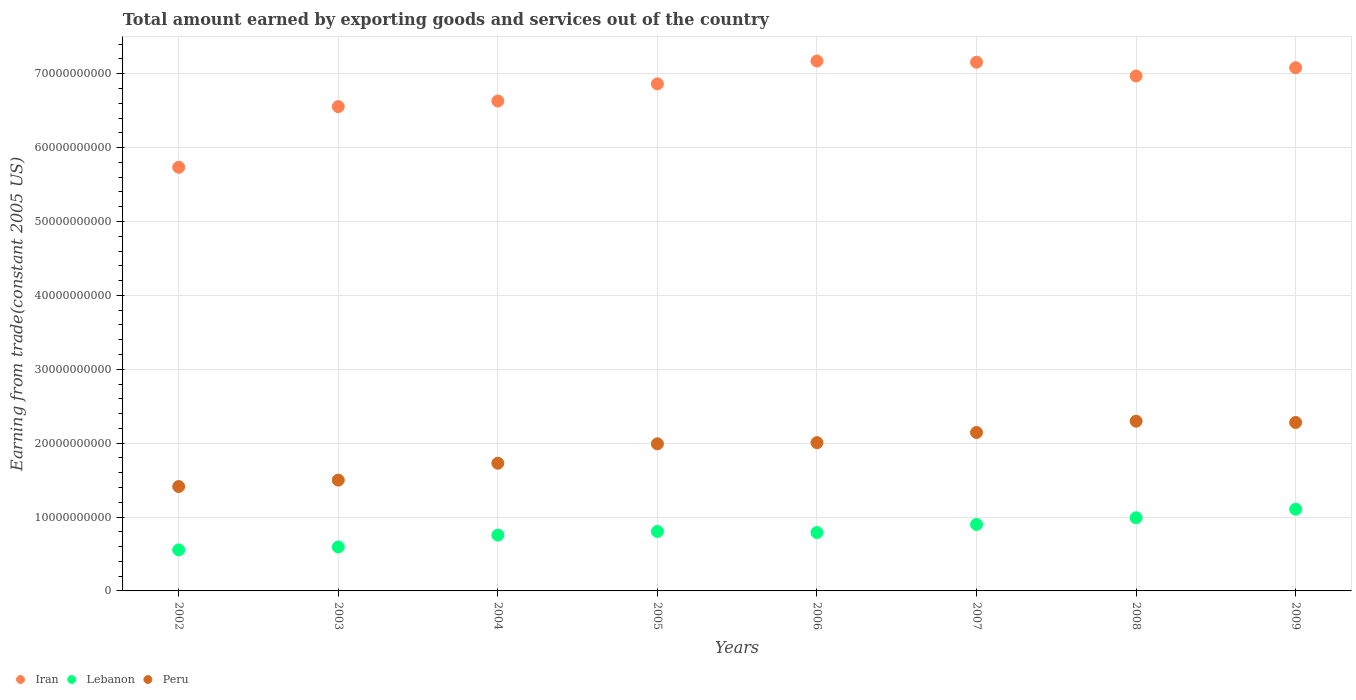Is the number of dotlines equal to the number of legend labels?
Your response must be concise. Yes. What is the total amount earned by exporting goods and services in Peru in 2003?
Keep it short and to the point. 1.50e+1. Across all years, what is the maximum total amount earned by exporting goods and services in Iran?
Ensure brevity in your answer.  7.17e+1. Across all years, what is the minimum total amount earned by exporting goods and services in Iran?
Offer a very short reply. 5.73e+1. What is the total total amount earned by exporting goods and services in Peru in the graph?
Offer a terse response. 1.54e+11. What is the difference between the total amount earned by exporting goods and services in Peru in 2002 and that in 2009?
Provide a short and direct response. -8.67e+09. What is the difference between the total amount earned by exporting goods and services in Peru in 2004 and the total amount earned by exporting goods and services in Lebanon in 2009?
Provide a short and direct response. 6.23e+09. What is the average total amount earned by exporting goods and services in Lebanon per year?
Give a very brief answer. 8.12e+09. In the year 2002, what is the difference between the total amount earned by exporting goods and services in Peru and total amount earned by exporting goods and services in Iran?
Make the answer very short. -4.32e+1. In how many years, is the total amount earned by exporting goods and services in Iran greater than 60000000000 US$?
Provide a succinct answer. 7. What is the ratio of the total amount earned by exporting goods and services in Iran in 2002 to that in 2009?
Give a very brief answer. 0.81. Is the difference between the total amount earned by exporting goods and services in Peru in 2007 and 2009 greater than the difference between the total amount earned by exporting goods and services in Iran in 2007 and 2009?
Give a very brief answer. No. What is the difference between the highest and the second highest total amount earned by exporting goods and services in Lebanon?
Your response must be concise. 1.15e+09. What is the difference between the highest and the lowest total amount earned by exporting goods and services in Lebanon?
Ensure brevity in your answer.  5.50e+09. In how many years, is the total amount earned by exporting goods and services in Peru greater than the average total amount earned by exporting goods and services in Peru taken over all years?
Provide a succinct answer. 5. Is it the case that in every year, the sum of the total amount earned by exporting goods and services in Lebanon and total amount earned by exporting goods and services in Peru  is greater than the total amount earned by exporting goods and services in Iran?
Offer a terse response. No. Does the total amount earned by exporting goods and services in Lebanon monotonically increase over the years?
Your answer should be compact. No. How many dotlines are there?
Your response must be concise. 3. Are the values on the major ticks of Y-axis written in scientific E-notation?
Provide a short and direct response. No. Does the graph contain grids?
Your response must be concise. Yes. Where does the legend appear in the graph?
Provide a succinct answer. Bottom left. How are the legend labels stacked?
Make the answer very short. Horizontal. What is the title of the graph?
Your response must be concise. Total amount earned by exporting goods and services out of the country. Does "Malta" appear as one of the legend labels in the graph?
Keep it short and to the point. No. What is the label or title of the X-axis?
Keep it short and to the point. Years. What is the label or title of the Y-axis?
Keep it short and to the point. Earning from trade(constant 2005 US). What is the Earning from trade(constant 2005 US) in Iran in 2002?
Your answer should be very brief. 5.73e+1. What is the Earning from trade(constant 2005 US) of Lebanon in 2002?
Your response must be concise. 5.56e+09. What is the Earning from trade(constant 2005 US) of Peru in 2002?
Ensure brevity in your answer.  1.41e+1. What is the Earning from trade(constant 2005 US) of Iran in 2003?
Offer a terse response. 6.56e+1. What is the Earning from trade(constant 2005 US) of Lebanon in 2003?
Offer a very short reply. 5.95e+09. What is the Earning from trade(constant 2005 US) in Peru in 2003?
Ensure brevity in your answer.  1.50e+1. What is the Earning from trade(constant 2005 US) in Iran in 2004?
Provide a short and direct response. 6.63e+1. What is the Earning from trade(constant 2005 US) of Lebanon in 2004?
Your answer should be compact. 7.56e+09. What is the Earning from trade(constant 2005 US) in Peru in 2004?
Make the answer very short. 1.73e+1. What is the Earning from trade(constant 2005 US) in Iran in 2005?
Keep it short and to the point. 6.86e+1. What is the Earning from trade(constant 2005 US) in Lebanon in 2005?
Provide a short and direct response. 8.05e+09. What is the Earning from trade(constant 2005 US) in Peru in 2005?
Your response must be concise. 1.99e+1. What is the Earning from trade(constant 2005 US) in Iran in 2006?
Provide a succinct answer. 7.17e+1. What is the Earning from trade(constant 2005 US) in Lebanon in 2006?
Ensure brevity in your answer.  7.91e+09. What is the Earning from trade(constant 2005 US) of Peru in 2006?
Make the answer very short. 2.01e+1. What is the Earning from trade(constant 2005 US) in Iran in 2007?
Provide a succinct answer. 7.16e+1. What is the Earning from trade(constant 2005 US) in Lebanon in 2007?
Make the answer very short. 9.00e+09. What is the Earning from trade(constant 2005 US) in Peru in 2007?
Provide a short and direct response. 2.14e+1. What is the Earning from trade(constant 2005 US) in Iran in 2008?
Your answer should be compact. 6.97e+1. What is the Earning from trade(constant 2005 US) in Lebanon in 2008?
Give a very brief answer. 9.91e+09. What is the Earning from trade(constant 2005 US) of Peru in 2008?
Offer a terse response. 2.30e+1. What is the Earning from trade(constant 2005 US) in Iran in 2009?
Your response must be concise. 7.08e+1. What is the Earning from trade(constant 2005 US) of Lebanon in 2009?
Make the answer very short. 1.11e+1. What is the Earning from trade(constant 2005 US) of Peru in 2009?
Offer a terse response. 2.28e+1. Across all years, what is the maximum Earning from trade(constant 2005 US) of Iran?
Your answer should be very brief. 7.17e+1. Across all years, what is the maximum Earning from trade(constant 2005 US) in Lebanon?
Your response must be concise. 1.11e+1. Across all years, what is the maximum Earning from trade(constant 2005 US) of Peru?
Offer a very short reply. 2.30e+1. Across all years, what is the minimum Earning from trade(constant 2005 US) of Iran?
Ensure brevity in your answer.  5.73e+1. Across all years, what is the minimum Earning from trade(constant 2005 US) in Lebanon?
Make the answer very short. 5.56e+09. Across all years, what is the minimum Earning from trade(constant 2005 US) of Peru?
Your answer should be compact. 1.41e+1. What is the total Earning from trade(constant 2005 US) of Iran in the graph?
Your response must be concise. 5.42e+11. What is the total Earning from trade(constant 2005 US) of Lebanon in the graph?
Keep it short and to the point. 6.50e+1. What is the total Earning from trade(constant 2005 US) in Peru in the graph?
Offer a terse response. 1.54e+11. What is the difference between the Earning from trade(constant 2005 US) of Iran in 2002 and that in 2003?
Provide a short and direct response. -8.21e+09. What is the difference between the Earning from trade(constant 2005 US) of Lebanon in 2002 and that in 2003?
Provide a succinct answer. -3.94e+08. What is the difference between the Earning from trade(constant 2005 US) of Peru in 2002 and that in 2003?
Offer a terse response. -8.71e+08. What is the difference between the Earning from trade(constant 2005 US) of Iran in 2002 and that in 2004?
Offer a very short reply. -8.97e+09. What is the difference between the Earning from trade(constant 2005 US) of Lebanon in 2002 and that in 2004?
Provide a succinct answer. -2.00e+09. What is the difference between the Earning from trade(constant 2005 US) in Peru in 2002 and that in 2004?
Your answer should be compact. -3.16e+09. What is the difference between the Earning from trade(constant 2005 US) of Iran in 2002 and that in 2005?
Ensure brevity in your answer.  -1.13e+1. What is the difference between the Earning from trade(constant 2005 US) of Lebanon in 2002 and that in 2005?
Make the answer very short. -2.49e+09. What is the difference between the Earning from trade(constant 2005 US) in Peru in 2002 and that in 2005?
Provide a short and direct response. -5.78e+09. What is the difference between the Earning from trade(constant 2005 US) of Iran in 2002 and that in 2006?
Ensure brevity in your answer.  -1.44e+1. What is the difference between the Earning from trade(constant 2005 US) of Lebanon in 2002 and that in 2006?
Your answer should be very brief. -2.35e+09. What is the difference between the Earning from trade(constant 2005 US) in Peru in 2002 and that in 2006?
Your answer should be very brief. -5.94e+09. What is the difference between the Earning from trade(constant 2005 US) of Iran in 2002 and that in 2007?
Provide a short and direct response. -1.42e+1. What is the difference between the Earning from trade(constant 2005 US) in Lebanon in 2002 and that in 2007?
Provide a short and direct response. -3.44e+09. What is the difference between the Earning from trade(constant 2005 US) in Peru in 2002 and that in 2007?
Provide a succinct answer. -7.32e+09. What is the difference between the Earning from trade(constant 2005 US) in Iran in 2002 and that in 2008?
Provide a short and direct response. -1.24e+1. What is the difference between the Earning from trade(constant 2005 US) of Lebanon in 2002 and that in 2008?
Your response must be concise. -4.35e+09. What is the difference between the Earning from trade(constant 2005 US) in Peru in 2002 and that in 2008?
Make the answer very short. -8.84e+09. What is the difference between the Earning from trade(constant 2005 US) of Iran in 2002 and that in 2009?
Give a very brief answer. -1.35e+1. What is the difference between the Earning from trade(constant 2005 US) in Lebanon in 2002 and that in 2009?
Your answer should be compact. -5.50e+09. What is the difference between the Earning from trade(constant 2005 US) of Peru in 2002 and that in 2009?
Keep it short and to the point. -8.67e+09. What is the difference between the Earning from trade(constant 2005 US) of Iran in 2003 and that in 2004?
Your answer should be compact. -7.56e+08. What is the difference between the Earning from trade(constant 2005 US) in Lebanon in 2003 and that in 2004?
Your response must be concise. -1.61e+09. What is the difference between the Earning from trade(constant 2005 US) of Peru in 2003 and that in 2004?
Ensure brevity in your answer.  -2.28e+09. What is the difference between the Earning from trade(constant 2005 US) of Iran in 2003 and that in 2005?
Offer a terse response. -3.08e+09. What is the difference between the Earning from trade(constant 2005 US) of Lebanon in 2003 and that in 2005?
Give a very brief answer. -2.10e+09. What is the difference between the Earning from trade(constant 2005 US) of Peru in 2003 and that in 2005?
Provide a short and direct response. -4.91e+09. What is the difference between the Earning from trade(constant 2005 US) in Iran in 2003 and that in 2006?
Ensure brevity in your answer.  -6.17e+09. What is the difference between the Earning from trade(constant 2005 US) in Lebanon in 2003 and that in 2006?
Your response must be concise. -1.96e+09. What is the difference between the Earning from trade(constant 2005 US) in Peru in 2003 and that in 2006?
Offer a very short reply. -5.07e+09. What is the difference between the Earning from trade(constant 2005 US) in Iran in 2003 and that in 2007?
Your answer should be compact. -6.01e+09. What is the difference between the Earning from trade(constant 2005 US) of Lebanon in 2003 and that in 2007?
Make the answer very short. -3.05e+09. What is the difference between the Earning from trade(constant 2005 US) of Peru in 2003 and that in 2007?
Offer a very short reply. -6.45e+09. What is the difference between the Earning from trade(constant 2005 US) in Iran in 2003 and that in 2008?
Make the answer very short. -4.15e+09. What is the difference between the Earning from trade(constant 2005 US) in Lebanon in 2003 and that in 2008?
Give a very brief answer. -3.95e+09. What is the difference between the Earning from trade(constant 2005 US) in Peru in 2003 and that in 2008?
Your answer should be very brief. -7.97e+09. What is the difference between the Earning from trade(constant 2005 US) of Iran in 2003 and that in 2009?
Keep it short and to the point. -5.27e+09. What is the difference between the Earning from trade(constant 2005 US) of Lebanon in 2003 and that in 2009?
Offer a very short reply. -5.11e+09. What is the difference between the Earning from trade(constant 2005 US) in Peru in 2003 and that in 2009?
Offer a very short reply. -7.80e+09. What is the difference between the Earning from trade(constant 2005 US) in Iran in 2004 and that in 2005?
Provide a succinct answer. -2.32e+09. What is the difference between the Earning from trade(constant 2005 US) of Lebanon in 2004 and that in 2005?
Provide a short and direct response. -4.93e+08. What is the difference between the Earning from trade(constant 2005 US) in Peru in 2004 and that in 2005?
Your answer should be compact. -2.63e+09. What is the difference between the Earning from trade(constant 2005 US) in Iran in 2004 and that in 2006?
Your answer should be very brief. -5.41e+09. What is the difference between the Earning from trade(constant 2005 US) in Lebanon in 2004 and that in 2006?
Ensure brevity in your answer.  -3.49e+08. What is the difference between the Earning from trade(constant 2005 US) of Peru in 2004 and that in 2006?
Offer a terse response. -2.79e+09. What is the difference between the Earning from trade(constant 2005 US) of Iran in 2004 and that in 2007?
Provide a succinct answer. -5.25e+09. What is the difference between the Earning from trade(constant 2005 US) of Lebanon in 2004 and that in 2007?
Make the answer very short. -1.44e+09. What is the difference between the Earning from trade(constant 2005 US) in Peru in 2004 and that in 2007?
Your answer should be very brief. -4.16e+09. What is the difference between the Earning from trade(constant 2005 US) of Iran in 2004 and that in 2008?
Your response must be concise. -3.39e+09. What is the difference between the Earning from trade(constant 2005 US) of Lebanon in 2004 and that in 2008?
Your answer should be very brief. -2.35e+09. What is the difference between the Earning from trade(constant 2005 US) of Peru in 2004 and that in 2008?
Give a very brief answer. -5.69e+09. What is the difference between the Earning from trade(constant 2005 US) of Iran in 2004 and that in 2009?
Make the answer very short. -4.51e+09. What is the difference between the Earning from trade(constant 2005 US) in Lebanon in 2004 and that in 2009?
Offer a terse response. -3.50e+09. What is the difference between the Earning from trade(constant 2005 US) of Peru in 2004 and that in 2009?
Your answer should be compact. -5.52e+09. What is the difference between the Earning from trade(constant 2005 US) in Iran in 2005 and that in 2006?
Keep it short and to the point. -3.09e+09. What is the difference between the Earning from trade(constant 2005 US) in Lebanon in 2005 and that in 2006?
Give a very brief answer. 1.44e+08. What is the difference between the Earning from trade(constant 2005 US) of Peru in 2005 and that in 2006?
Ensure brevity in your answer.  -1.59e+08. What is the difference between the Earning from trade(constant 2005 US) in Iran in 2005 and that in 2007?
Keep it short and to the point. -2.93e+09. What is the difference between the Earning from trade(constant 2005 US) of Lebanon in 2005 and that in 2007?
Make the answer very short. -9.45e+08. What is the difference between the Earning from trade(constant 2005 US) in Peru in 2005 and that in 2007?
Offer a terse response. -1.53e+09. What is the difference between the Earning from trade(constant 2005 US) of Iran in 2005 and that in 2008?
Make the answer very short. -1.07e+09. What is the difference between the Earning from trade(constant 2005 US) in Lebanon in 2005 and that in 2008?
Offer a terse response. -1.85e+09. What is the difference between the Earning from trade(constant 2005 US) in Peru in 2005 and that in 2008?
Provide a succinct answer. -3.06e+09. What is the difference between the Earning from trade(constant 2005 US) in Iran in 2005 and that in 2009?
Make the answer very short. -2.19e+09. What is the difference between the Earning from trade(constant 2005 US) of Lebanon in 2005 and that in 2009?
Provide a short and direct response. -3.01e+09. What is the difference between the Earning from trade(constant 2005 US) of Peru in 2005 and that in 2009?
Offer a very short reply. -2.89e+09. What is the difference between the Earning from trade(constant 2005 US) of Iran in 2006 and that in 2007?
Give a very brief answer. 1.61e+08. What is the difference between the Earning from trade(constant 2005 US) in Lebanon in 2006 and that in 2007?
Provide a succinct answer. -1.09e+09. What is the difference between the Earning from trade(constant 2005 US) of Peru in 2006 and that in 2007?
Your response must be concise. -1.37e+09. What is the difference between the Earning from trade(constant 2005 US) in Iran in 2006 and that in 2008?
Provide a short and direct response. 2.02e+09. What is the difference between the Earning from trade(constant 2005 US) of Lebanon in 2006 and that in 2008?
Provide a succinct answer. -2.00e+09. What is the difference between the Earning from trade(constant 2005 US) in Peru in 2006 and that in 2008?
Your answer should be very brief. -2.90e+09. What is the difference between the Earning from trade(constant 2005 US) in Iran in 2006 and that in 2009?
Your answer should be very brief. 9.05e+08. What is the difference between the Earning from trade(constant 2005 US) in Lebanon in 2006 and that in 2009?
Your answer should be compact. -3.15e+09. What is the difference between the Earning from trade(constant 2005 US) of Peru in 2006 and that in 2009?
Provide a succinct answer. -2.73e+09. What is the difference between the Earning from trade(constant 2005 US) in Iran in 2007 and that in 2008?
Your response must be concise. 1.86e+09. What is the difference between the Earning from trade(constant 2005 US) in Lebanon in 2007 and that in 2008?
Keep it short and to the point. -9.10e+08. What is the difference between the Earning from trade(constant 2005 US) of Peru in 2007 and that in 2008?
Your response must be concise. -1.52e+09. What is the difference between the Earning from trade(constant 2005 US) in Iran in 2007 and that in 2009?
Offer a terse response. 7.44e+08. What is the difference between the Earning from trade(constant 2005 US) in Lebanon in 2007 and that in 2009?
Provide a short and direct response. -2.06e+09. What is the difference between the Earning from trade(constant 2005 US) of Peru in 2007 and that in 2009?
Provide a short and direct response. -1.36e+09. What is the difference between the Earning from trade(constant 2005 US) of Iran in 2008 and that in 2009?
Give a very brief answer. -1.12e+09. What is the difference between the Earning from trade(constant 2005 US) in Lebanon in 2008 and that in 2009?
Make the answer very short. -1.15e+09. What is the difference between the Earning from trade(constant 2005 US) in Peru in 2008 and that in 2009?
Keep it short and to the point. 1.67e+08. What is the difference between the Earning from trade(constant 2005 US) in Iran in 2002 and the Earning from trade(constant 2005 US) in Lebanon in 2003?
Offer a very short reply. 5.14e+1. What is the difference between the Earning from trade(constant 2005 US) in Iran in 2002 and the Earning from trade(constant 2005 US) in Peru in 2003?
Ensure brevity in your answer.  4.23e+1. What is the difference between the Earning from trade(constant 2005 US) in Lebanon in 2002 and the Earning from trade(constant 2005 US) in Peru in 2003?
Provide a short and direct response. -9.44e+09. What is the difference between the Earning from trade(constant 2005 US) in Iran in 2002 and the Earning from trade(constant 2005 US) in Lebanon in 2004?
Give a very brief answer. 4.98e+1. What is the difference between the Earning from trade(constant 2005 US) of Iran in 2002 and the Earning from trade(constant 2005 US) of Peru in 2004?
Your response must be concise. 4.01e+1. What is the difference between the Earning from trade(constant 2005 US) of Lebanon in 2002 and the Earning from trade(constant 2005 US) of Peru in 2004?
Provide a short and direct response. -1.17e+1. What is the difference between the Earning from trade(constant 2005 US) in Iran in 2002 and the Earning from trade(constant 2005 US) in Lebanon in 2005?
Offer a terse response. 4.93e+1. What is the difference between the Earning from trade(constant 2005 US) in Iran in 2002 and the Earning from trade(constant 2005 US) in Peru in 2005?
Your response must be concise. 3.74e+1. What is the difference between the Earning from trade(constant 2005 US) in Lebanon in 2002 and the Earning from trade(constant 2005 US) in Peru in 2005?
Make the answer very short. -1.44e+1. What is the difference between the Earning from trade(constant 2005 US) in Iran in 2002 and the Earning from trade(constant 2005 US) in Lebanon in 2006?
Ensure brevity in your answer.  4.94e+1. What is the difference between the Earning from trade(constant 2005 US) of Iran in 2002 and the Earning from trade(constant 2005 US) of Peru in 2006?
Give a very brief answer. 3.73e+1. What is the difference between the Earning from trade(constant 2005 US) in Lebanon in 2002 and the Earning from trade(constant 2005 US) in Peru in 2006?
Provide a short and direct response. -1.45e+1. What is the difference between the Earning from trade(constant 2005 US) of Iran in 2002 and the Earning from trade(constant 2005 US) of Lebanon in 2007?
Give a very brief answer. 4.83e+1. What is the difference between the Earning from trade(constant 2005 US) in Iran in 2002 and the Earning from trade(constant 2005 US) in Peru in 2007?
Provide a short and direct response. 3.59e+1. What is the difference between the Earning from trade(constant 2005 US) in Lebanon in 2002 and the Earning from trade(constant 2005 US) in Peru in 2007?
Offer a very short reply. -1.59e+1. What is the difference between the Earning from trade(constant 2005 US) of Iran in 2002 and the Earning from trade(constant 2005 US) of Lebanon in 2008?
Your response must be concise. 4.74e+1. What is the difference between the Earning from trade(constant 2005 US) of Iran in 2002 and the Earning from trade(constant 2005 US) of Peru in 2008?
Make the answer very short. 3.44e+1. What is the difference between the Earning from trade(constant 2005 US) in Lebanon in 2002 and the Earning from trade(constant 2005 US) in Peru in 2008?
Make the answer very short. -1.74e+1. What is the difference between the Earning from trade(constant 2005 US) of Iran in 2002 and the Earning from trade(constant 2005 US) of Lebanon in 2009?
Your answer should be compact. 4.63e+1. What is the difference between the Earning from trade(constant 2005 US) of Iran in 2002 and the Earning from trade(constant 2005 US) of Peru in 2009?
Offer a very short reply. 3.45e+1. What is the difference between the Earning from trade(constant 2005 US) in Lebanon in 2002 and the Earning from trade(constant 2005 US) in Peru in 2009?
Your response must be concise. -1.72e+1. What is the difference between the Earning from trade(constant 2005 US) of Iran in 2003 and the Earning from trade(constant 2005 US) of Lebanon in 2004?
Provide a short and direct response. 5.80e+1. What is the difference between the Earning from trade(constant 2005 US) of Iran in 2003 and the Earning from trade(constant 2005 US) of Peru in 2004?
Ensure brevity in your answer.  4.83e+1. What is the difference between the Earning from trade(constant 2005 US) of Lebanon in 2003 and the Earning from trade(constant 2005 US) of Peru in 2004?
Provide a succinct answer. -1.13e+1. What is the difference between the Earning from trade(constant 2005 US) of Iran in 2003 and the Earning from trade(constant 2005 US) of Lebanon in 2005?
Your answer should be very brief. 5.75e+1. What is the difference between the Earning from trade(constant 2005 US) of Iran in 2003 and the Earning from trade(constant 2005 US) of Peru in 2005?
Your answer should be compact. 4.56e+1. What is the difference between the Earning from trade(constant 2005 US) of Lebanon in 2003 and the Earning from trade(constant 2005 US) of Peru in 2005?
Offer a terse response. -1.40e+1. What is the difference between the Earning from trade(constant 2005 US) in Iran in 2003 and the Earning from trade(constant 2005 US) in Lebanon in 2006?
Provide a short and direct response. 5.77e+1. What is the difference between the Earning from trade(constant 2005 US) of Iran in 2003 and the Earning from trade(constant 2005 US) of Peru in 2006?
Offer a terse response. 4.55e+1. What is the difference between the Earning from trade(constant 2005 US) in Lebanon in 2003 and the Earning from trade(constant 2005 US) in Peru in 2006?
Your answer should be very brief. -1.41e+1. What is the difference between the Earning from trade(constant 2005 US) in Iran in 2003 and the Earning from trade(constant 2005 US) in Lebanon in 2007?
Your answer should be very brief. 5.66e+1. What is the difference between the Earning from trade(constant 2005 US) in Iran in 2003 and the Earning from trade(constant 2005 US) in Peru in 2007?
Your answer should be very brief. 4.41e+1. What is the difference between the Earning from trade(constant 2005 US) in Lebanon in 2003 and the Earning from trade(constant 2005 US) in Peru in 2007?
Your answer should be compact. -1.55e+1. What is the difference between the Earning from trade(constant 2005 US) of Iran in 2003 and the Earning from trade(constant 2005 US) of Lebanon in 2008?
Offer a very short reply. 5.57e+1. What is the difference between the Earning from trade(constant 2005 US) of Iran in 2003 and the Earning from trade(constant 2005 US) of Peru in 2008?
Give a very brief answer. 4.26e+1. What is the difference between the Earning from trade(constant 2005 US) in Lebanon in 2003 and the Earning from trade(constant 2005 US) in Peru in 2008?
Your response must be concise. -1.70e+1. What is the difference between the Earning from trade(constant 2005 US) in Iran in 2003 and the Earning from trade(constant 2005 US) in Lebanon in 2009?
Make the answer very short. 5.45e+1. What is the difference between the Earning from trade(constant 2005 US) of Iran in 2003 and the Earning from trade(constant 2005 US) of Peru in 2009?
Offer a very short reply. 4.28e+1. What is the difference between the Earning from trade(constant 2005 US) in Lebanon in 2003 and the Earning from trade(constant 2005 US) in Peru in 2009?
Offer a terse response. -1.69e+1. What is the difference between the Earning from trade(constant 2005 US) in Iran in 2004 and the Earning from trade(constant 2005 US) in Lebanon in 2005?
Make the answer very short. 5.83e+1. What is the difference between the Earning from trade(constant 2005 US) in Iran in 2004 and the Earning from trade(constant 2005 US) in Peru in 2005?
Make the answer very short. 4.64e+1. What is the difference between the Earning from trade(constant 2005 US) in Lebanon in 2004 and the Earning from trade(constant 2005 US) in Peru in 2005?
Your response must be concise. -1.24e+1. What is the difference between the Earning from trade(constant 2005 US) in Iran in 2004 and the Earning from trade(constant 2005 US) in Lebanon in 2006?
Your answer should be very brief. 5.84e+1. What is the difference between the Earning from trade(constant 2005 US) of Iran in 2004 and the Earning from trade(constant 2005 US) of Peru in 2006?
Your response must be concise. 4.62e+1. What is the difference between the Earning from trade(constant 2005 US) of Lebanon in 2004 and the Earning from trade(constant 2005 US) of Peru in 2006?
Offer a terse response. -1.25e+1. What is the difference between the Earning from trade(constant 2005 US) of Iran in 2004 and the Earning from trade(constant 2005 US) of Lebanon in 2007?
Your answer should be very brief. 5.73e+1. What is the difference between the Earning from trade(constant 2005 US) in Iran in 2004 and the Earning from trade(constant 2005 US) in Peru in 2007?
Your answer should be compact. 4.49e+1. What is the difference between the Earning from trade(constant 2005 US) of Lebanon in 2004 and the Earning from trade(constant 2005 US) of Peru in 2007?
Give a very brief answer. -1.39e+1. What is the difference between the Earning from trade(constant 2005 US) of Iran in 2004 and the Earning from trade(constant 2005 US) of Lebanon in 2008?
Offer a very short reply. 5.64e+1. What is the difference between the Earning from trade(constant 2005 US) of Iran in 2004 and the Earning from trade(constant 2005 US) of Peru in 2008?
Make the answer very short. 4.33e+1. What is the difference between the Earning from trade(constant 2005 US) of Lebanon in 2004 and the Earning from trade(constant 2005 US) of Peru in 2008?
Your answer should be compact. -1.54e+1. What is the difference between the Earning from trade(constant 2005 US) of Iran in 2004 and the Earning from trade(constant 2005 US) of Lebanon in 2009?
Offer a very short reply. 5.53e+1. What is the difference between the Earning from trade(constant 2005 US) in Iran in 2004 and the Earning from trade(constant 2005 US) in Peru in 2009?
Offer a terse response. 4.35e+1. What is the difference between the Earning from trade(constant 2005 US) of Lebanon in 2004 and the Earning from trade(constant 2005 US) of Peru in 2009?
Offer a very short reply. -1.52e+1. What is the difference between the Earning from trade(constant 2005 US) of Iran in 2005 and the Earning from trade(constant 2005 US) of Lebanon in 2006?
Offer a very short reply. 6.07e+1. What is the difference between the Earning from trade(constant 2005 US) of Iran in 2005 and the Earning from trade(constant 2005 US) of Peru in 2006?
Provide a short and direct response. 4.86e+1. What is the difference between the Earning from trade(constant 2005 US) in Lebanon in 2005 and the Earning from trade(constant 2005 US) in Peru in 2006?
Your answer should be very brief. -1.20e+1. What is the difference between the Earning from trade(constant 2005 US) of Iran in 2005 and the Earning from trade(constant 2005 US) of Lebanon in 2007?
Provide a short and direct response. 5.96e+1. What is the difference between the Earning from trade(constant 2005 US) of Iran in 2005 and the Earning from trade(constant 2005 US) of Peru in 2007?
Provide a short and direct response. 4.72e+1. What is the difference between the Earning from trade(constant 2005 US) in Lebanon in 2005 and the Earning from trade(constant 2005 US) in Peru in 2007?
Provide a short and direct response. -1.34e+1. What is the difference between the Earning from trade(constant 2005 US) of Iran in 2005 and the Earning from trade(constant 2005 US) of Lebanon in 2008?
Offer a terse response. 5.87e+1. What is the difference between the Earning from trade(constant 2005 US) in Iran in 2005 and the Earning from trade(constant 2005 US) in Peru in 2008?
Ensure brevity in your answer.  4.57e+1. What is the difference between the Earning from trade(constant 2005 US) of Lebanon in 2005 and the Earning from trade(constant 2005 US) of Peru in 2008?
Offer a very short reply. -1.49e+1. What is the difference between the Earning from trade(constant 2005 US) of Iran in 2005 and the Earning from trade(constant 2005 US) of Lebanon in 2009?
Keep it short and to the point. 5.76e+1. What is the difference between the Earning from trade(constant 2005 US) of Iran in 2005 and the Earning from trade(constant 2005 US) of Peru in 2009?
Your answer should be very brief. 4.58e+1. What is the difference between the Earning from trade(constant 2005 US) of Lebanon in 2005 and the Earning from trade(constant 2005 US) of Peru in 2009?
Offer a very short reply. -1.48e+1. What is the difference between the Earning from trade(constant 2005 US) of Iran in 2006 and the Earning from trade(constant 2005 US) of Lebanon in 2007?
Give a very brief answer. 6.27e+1. What is the difference between the Earning from trade(constant 2005 US) in Iran in 2006 and the Earning from trade(constant 2005 US) in Peru in 2007?
Make the answer very short. 5.03e+1. What is the difference between the Earning from trade(constant 2005 US) of Lebanon in 2006 and the Earning from trade(constant 2005 US) of Peru in 2007?
Ensure brevity in your answer.  -1.35e+1. What is the difference between the Earning from trade(constant 2005 US) in Iran in 2006 and the Earning from trade(constant 2005 US) in Lebanon in 2008?
Provide a succinct answer. 6.18e+1. What is the difference between the Earning from trade(constant 2005 US) of Iran in 2006 and the Earning from trade(constant 2005 US) of Peru in 2008?
Your answer should be very brief. 4.88e+1. What is the difference between the Earning from trade(constant 2005 US) in Lebanon in 2006 and the Earning from trade(constant 2005 US) in Peru in 2008?
Make the answer very short. -1.51e+1. What is the difference between the Earning from trade(constant 2005 US) of Iran in 2006 and the Earning from trade(constant 2005 US) of Lebanon in 2009?
Make the answer very short. 6.07e+1. What is the difference between the Earning from trade(constant 2005 US) of Iran in 2006 and the Earning from trade(constant 2005 US) of Peru in 2009?
Your response must be concise. 4.89e+1. What is the difference between the Earning from trade(constant 2005 US) in Lebanon in 2006 and the Earning from trade(constant 2005 US) in Peru in 2009?
Provide a short and direct response. -1.49e+1. What is the difference between the Earning from trade(constant 2005 US) in Iran in 2007 and the Earning from trade(constant 2005 US) in Lebanon in 2008?
Give a very brief answer. 6.17e+1. What is the difference between the Earning from trade(constant 2005 US) of Iran in 2007 and the Earning from trade(constant 2005 US) of Peru in 2008?
Give a very brief answer. 4.86e+1. What is the difference between the Earning from trade(constant 2005 US) in Lebanon in 2007 and the Earning from trade(constant 2005 US) in Peru in 2008?
Give a very brief answer. -1.40e+1. What is the difference between the Earning from trade(constant 2005 US) of Iran in 2007 and the Earning from trade(constant 2005 US) of Lebanon in 2009?
Your answer should be compact. 6.05e+1. What is the difference between the Earning from trade(constant 2005 US) of Iran in 2007 and the Earning from trade(constant 2005 US) of Peru in 2009?
Offer a very short reply. 4.88e+1. What is the difference between the Earning from trade(constant 2005 US) of Lebanon in 2007 and the Earning from trade(constant 2005 US) of Peru in 2009?
Ensure brevity in your answer.  -1.38e+1. What is the difference between the Earning from trade(constant 2005 US) in Iran in 2008 and the Earning from trade(constant 2005 US) in Lebanon in 2009?
Provide a short and direct response. 5.86e+1. What is the difference between the Earning from trade(constant 2005 US) in Iran in 2008 and the Earning from trade(constant 2005 US) in Peru in 2009?
Make the answer very short. 4.69e+1. What is the difference between the Earning from trade(constant 2005 US) in Lebanon in 2008 and the Earning from trade(constant 2005 US) in Peru in 2009?
Provide a short and direct response. -1.29e+1. What is the average Earning from trade(constant 2005 US) of Iran per year?
Provide a short and direct response. 6.77e+1. What is the average Earning from trade(constant 2005 US) in Lebanon per year?
Provide a short and direct response. 8.12e+09. What is the average Earning from trade(constant 2005 US) in Peru per year?
Your answer should be compact. 1.92e+1. In the year 2002, what is the difference between the Earning from trade(constant 2005 US) in Iran and Earning from trade(constant 2005 US) in Lebanon?
Make the answer very short. 5.18e+1. In the year 2002, what is the difference between the Earning from trade(constant 2005 US) in Iran and Earning from trade(constant 2005 US) in Peru?
Your answer should be very brief. 4.32e+1. In the year 2002, what is the difference between the Earning from trade(constant 2005 US) of Lebanon and Earning from trade(constant 2005 US) of Peru?
Offer a terse response. -8.57e+09. In the year 2003, what is the difference between the Earning from trade(constant 2005 US) of Iran and Earning from trade(constant 2005 US) of Lebanon?
Provide a short and direct response. 5.96e+1. In the year 2003, what is the difference between the Earning from trade(constant 2005 US) in Iran and Earning from trade(constant 2005 US) in Peru?
Ensure brevity in your answer.  5.06e+1. In the year 2003, what is the difference between the Earning from trade(constant 2005 US) of Lebanon and Earning from trade(constant 2005 US) of Peru?
Your answer should be compact. -9.05e+09. In the year 2004, what is the difference between the Earning from trade(constant 2005 US) of Iran and Earning from trade(constant 2005 US) of Lebanon?
Provide a short and direct response. 5.88e+1. In the year 2004, what is the difference between the Earning from trade(constant 2005 US) of Iran and Earning from trade(constant 2005 US) of Peru?
Give a very brief answer. 4.90e+1. In the year 2004, what is the difference between the Earning from trade(constant 2005 US) in Lebanon and Earning from trade(constant 2005 US) in Peru?
Your answer should be compact. -9.73e+09. In the year 2005, what is the difference between the Earning from trade(constant 2005 US) in Iran and Earning from trade(constant 2005 US) in Lebanon?
Your answer should be very brief. 6.06e+1. In the year 2005, what is the difference between the Earning from trade(constant 2005 US) of Iran and Earning from trade(constant 2005 US) of Peru?
Your answer should be compact. 4.87e+1. In the year 2005, what is the difference between the Earning from trade(constant 2005 US) of Lebanon and Earning from trade(constant 2005 US) of Peru?
Give a very brief answer. -1.19e+1. In the year 2006, what is the difference between the Earning from trade(constant 2005 US) in Iran and Earning from trade(constant 2005 US) in Lebanon?
Provide a short and direct response. 6.38e+1. In the year 2006, what is the difference between the Earning from trade(constant 2005 US) in Iran and Earning from trade(constant 2005 US) in Peru?
Provide a short and direct response. 5.17e+1. In the year 2006, what is the difference between the Earning from trade(constant 2005 US) in Lebanon and Earning from trade(constant 2005 US) in Peru?
Make the answer very short. -1.22e+1. In the year 2007, what is the difference between the Earning from trade(constant 2005 US) of Iran and Earning from trade(constant 2005 US) of Lebanon?
Keep it short and to the point. 6.26e+1. In the year 2007, what is the difference between the Earning from trade(constant 2005 US) of Iran and Earning from trade(constant 2005 US) of Peru?
Provide a succinct answer. 5.01e+1. In the year 2007, what is the difference between the Earning from trade(constant 2005 US) in Lebanon and Earning from trade(constant 2005 US) in Peru?
Offer a very short reply. -1.25e+1. In the year 2008, what is the difference between the Earning from trade(constant 2005 US) in Iran and Earning from trade(constant 2005 US) in Lebanon?
Make the answer very short. 5.98e+1. In the year 2008, what is the difference between the Earning from trade(constant 2005 US) in Iran and Earning from trade(constant 2005 US) in Peru?
Your response must be concise. 4.67e+1. In the year 2008, what is the difference between the Earning from trade(constant 2005 US) of Lebanon and Earning from trade(constant 2005 US) of Peru?
Give a very brief answer. -1.31e+1. In the year 2009, what is the difference between the Earning from trade(constant 2005 US) in Iran and Earning from trade(constant 2005 US) in Lebanon?
Offer a terse response. 5.98e+1. In the year 2009, what is the difference between the Earning from trade(constant 2005 US) of Iran and Earning from trade(constant 2005 US) of Peru?
Offer a very short reply. 4.80e+1. In the year 2009, what is the difference between the Earning from trade(constant 2005 US) of Lebanon and Earning from trade(constant 2005 US) of Peru?
Provide a succinct answer. -1.17e+1. What is the ratio of the Earning from trade(constant 2005 US) of Iran in 2002 to that in 2003?
Offer a terse response. 0.87. What is the ratio of the Earning from trade(constant 2005 US) in Lebanon in 2002 to that in 2003?
Give a very brief answer. 0.93. What is the ratio of the Earning from trade(constant 2005 US) of Peru in 2002 to that in 2003?
Keep it short and to the point. 0.94. What is the ratio of the Earning from trade(constant 2005 US) of Iran in 2002 to that in 2004?
Keep it short and to the point. 0.86. What is the ratio of the Earning from trade(constant 2005 US) of Lebanon in 2002 to that in 2004?
Provide a succinct answer. 0.74. What is the ratio of the Earning from trade(constant 2005 US) of Peru in 2002 to that in 2004?
Provide a succinct answer. 0.82. What is the ratio of the Earning from trade(constant 2005 US) in Iran in 2002 to that in 2005?
Your answer should be compact. 0.84. What is the ratio of the Earning from trade(constant 2005 US) of Lebanon in 2002 to that in 2005?
Make the answer very short. 0.69. What is the ratio of the Earning from trade(constant 2005 US) in Peru in 2002 to that in 2005?
Offer a very short reply. 0.71. What is the ratio of the Earning from trade(constant 2005 US) of Iran in 2002 to that in 2006?
Give a very brief answer. 0.8. What is the ratio of the Earning from trade(constant 2005 US) of Lebanon in 2002 to that in 2006?
Offer a terse response. 0.7. What is the ratio of the Earning from trade(constant 2005 US) in Peru in 2002 to that in 2006?
Make the answer very short. 0.7. What is the ratio of the Earning from trade(constant 2005 US) in Iran in 2002 to that in 2007?
Give a very brief answer. 0.8. What is the ratio of the Earning from trade(constant 2005 US) of Lebanon in 2002 to that in 2007?
Make the answer very short. 0.62. What is the ratio of the Earning from trade(constant 2005 US) in Peru in 2002 to that in 2007?
Keep it short and to the point. 0.66. What is the ratio of the Earning from trade(constant 2005 US) in Iran in 2002 to that in 2008?
Offer a terse response. 0.82. What is the ratio of the Earning from trade(constant 2005 US) of Lebanon in 2002 to that in 2008?
Make the answer very short. 0.56. What is the ratio of the Earning from trade(constant 2005 US) of Peru in 2002 to that in 2008?
Your answer should be compact. 0.62. What is the ratio of the Earning from trade(constant 2005 US) in Iran in 2002 to that in 2009?
Provide a short and direct response. 0.81. What is the ratio of the Earning from trade(constant 2005 US) of Lebanon in 2002 to that in 2009?
Keep it short and to the point. 0.5. What is the ratio of the Earning from trade(constant 2005 US) in Peru in 2002 to that in 2009?
Provide a short and direct response. 0.62. What is the ratio of the Earning from trade(constant 2005 US) in Iran in 2003 to that in 2004?
Offer a very short reply. 0.99. What is the ratio of the Earning from trade(constant 2005 US) in Lebanon in 2003 to that in 2004?
Make the answer very short. 0.79. What is the ratio of the Earning from trade(constant 2005 US) in Peru in 2003 to that in 2004?
Your response must be concise. 0.87. What is the ratio of the Earning from trade(constant 2005 US) in Iran in 2003 to that in 2005?
Make the answer very short. 0.96. What is the ratio of the Earning from trade(constant 2005 US) of Lebanon in 2003 to that in 2005?
Your answer should be very brief. 0.74. What is the ratio of the Earning from trade(constant 2005 US) in Peru in 2003 to that in 2005?
Keep it short and to the point. 0.75. What is the ratio of the Earning from trade(constant 2005 US) of Iran in 2003 to that in 2006?
Your response must be concise. 0.91. What is the ratio of the Earning from trade(constant 2005 US) of Lebanon in 2003 to that in 2006?
Your response must be concise. 0.75. What is the ratio of the Earning from trade(constant 2005 US) in Peru in 2003 to that in 2006?
Make the answer very short. 0.75. What is the ratio of the Earning from trade(constant 2005 US) of Iran in 2003 to that in 2007?
Provide a succinct answer. 0.92. What is the ratio of the Earning from trade(constant 2005 US) in Lebanon in 2003 to that in 2007?
Keep it short and to the point. 0.66. What is the ratio of the Earning from trade(constant 2005 US) in Peru in 2003 to that in 2007?
Your answer should be very brief. 0.7. What is the ratio of the Earning from trade(constant 2005 US) in Iran in 2003 to that in 2008?
Provide a short and direct response. 0.94. What is the ratio of the Earning from trade(constant 2005 US) of Lebanon in 2003 to that in 2008?
Offer a very short reply. 0.6. What is the ratio of the Earning from trade(constant 2005 US) of Peru in 2003 to that in 2008?
Keep it short and to the point. 0.65. What is the ratio of the Earning from trade(constant 2005 US) of Iran in 2003 to that in 2009?
Provide a short and direct response. 0.93. What is the ratio of the Earning from trade(constant 2005 US) in Lebanon in 2003 to that in 2009?
Your answer should be compact. 0.54. What is the ratio of the Earning from trade(constant 2005 US) in Peru in 2003 to that in 2009?
Your answer should be compact. 0.66. What is the ratio of the Earning from trade(constant 2005 US) of Iran in 2004 to that in 2005?
Your answer should be very brief. 0.97. What is the ratio of the Earning from trade(constant 2005 US) in Lebanon in 2004 to that in 2005?
Ensure brevity in your answer.  0.94. What is the ratio of the Earning from trade(constant 2005 US) of Peru in 2004 to that in 2005?
Give a very brief answer. 0.87. What is the ratio of the Earning from trade(constant 2005 US) in Iran in 2004 to that in 2006?
Keep it short and to the point. 0.92. What is the ratio of the Earning from trade(constant 2005 US) in Lebanon in 2004 to that in 2006?
Your response must be concise. 0.96. What is the ratio of the Earning from trade(constant 2005 US) of Peru in 2004 to that in 2006?
Provide a short and direct response. 0.86. What is the ratio of the Earning from trade(constant 2005 US) in Iran in 2004 to that in 2007?
Your answer should be very brief. 0.93. What is the ratio of the Earning from trade(constant 2005 US) of Lebanon in 2004 to that in 2007?
Keep it short and to the point. 0.84. What is the ratio of the Earning from trade(constant 2005 US) in Peru in 2004 to that in 2007?
Make the answer very short. 0.81. What is the ratio of the Earning from trade(constant 2005 US) in Iran in 2004 to that in 2008?
Offer a terse response. 0.95. What is the ratio of the Earning from trade(constant 2005 US) of Lebanon in 2004 to that in 2008?
Your answer should be compact. 0.76. What is the ratio of the Earning from trade(constant 2005 US) in Peru in 2004 to that in 2008?
Your answer should be very brief. 0.75. What is the ratio of the Earning from trade(constant 2005 US) of Iran in 2004 to that in 2009?
Your answer should be very brief. 0.94. What is the ratio of the Earning from trade(constant 2005 US) in Lebanon in 2004 to that in 2009?
Offer a very short reply. 0.68. What is the ratio of the Earning from trade(constant 2005 US) in Peru in 2004 to that in 2009?
Offer a very short reply. 0.76. What is the ratio of the Earning from trade(constant 2005 US) in Iran in 2005 to that in 2006?
Your response must be concise. 0.96. What is the ratio of the Earning from trade(constant 2005 US) of Lebanon in 2005 to that in 2006?
Offer a terse response. 1.02. What is the ratio of the Earning from trade(constant 2005 US) in Iran in 2005 to that in 2007?
Your answer should be very brief. 0.96. What is the ratio of the Earning from trade(constant 2005 US) in Lebanon in 2005 to that in 2007?
Ensure brevity in your answer.  0.89. What is the ratio of the Earning from trade(constant 2005 US) in Peru in 2005 to that in 2007?
Keep it short and to the point. 0.93. What is the ratio of the Earning from trade(constant 2005 US) in Iran in 2005 to that in 2008?
Offer a terse response. 0.98. What is the ratio of the Earning from trade(constant 2005 US) in Lebanon in 2005 to that in 2008?
Ensure brevity in your answer.  0.81. What is the ratio of the Earning from trade(constant 2005 US) in Peru in 2005 to that in 2008?
Provide a succinct answer. 0.87. What is the ratio of the Earning from trade(constant 2005 US) in Iran in 2005 to that in 2009?
Your answer should be very brief. 0.97. What is the ratio of the Earning from trade(constant 2005 US) of Lebanon in 2005 to that in 2009?
Make the answer very short. 0.73. What is the ratio of the Earning from trade(constant 2005 US) in Peru in 2005 to that in 2009?
Offer a terse response. 0.87. What is the ratio of the Earning from trade(constant 2005 US) in Iran in 2006 to that in 2007?
Your response must be concise. 1. What is the ratio of the Earning from trade(constant 2005 US) of Lebanon in 2006 to that in 2007?
Your answer should be compact. 0.88. What is the ratio of the Earning from trade(constant 2005 US) in Peru in 2006 to that in 2007?
Offer a very short reply. 0.94. What is the ratio of the Earning from trade(constant 2005 US) of Lebanon in 2006 to that in 2008?
Ensure brevity in your answer.  0.8. What is the ratio of the Earning from trade(constant 2005 US) of Peru in 2006 to that in 2008?
Your response must be concise. 0.87. What is the ratio of the Earning from trade(constant 2005 US) of Iran in 2006 to that in 2009?
Offer a terse response. 1.01. What is the ratio of the Earning from trade(constant 2005 US) of Lebanon in 2006 to that in 2009?
Your response must be concise. 0.71. What is the ratio of the Earning from trade(constant 2005 US) of Peru in 2006 to that in 2009?
Give a very brief answer. 0.88. What is the ratio of the Earning from trade(constant 2005 US) in Iran in 2007 to that in 2008?
Offer a terse response. 1.03. What is the ratio of the Earning from trade(constant 2005 US) in Lebanon in 2007 to that in 2008?
Provide a succinct answer. 0.91. What is the ratio of the Earning from trade(constant 2005 US) of Peru in 2007 to that in 2008?
Make the answer very short. 0.93. What is the ratio of the Earning from trade(constant 2005 US) of Iran in 2007 to that in 2009?
Offer a very short reply. 1.01. What is the ratio of the Earning from trade(constant 2005 US) of Lebanon in 2007 to that in 2009?
Your answer should be very brief. 0.81. What is the ratio of the Earning from trade(constant 2005 US) in Peru in 2007 to that in 2009?
Give a very brief answer. 0.94. What is the ratio of the Earning from trade(constant 2005 US) in Iran in 2008 to that in 2009?
Keep it short and to the point. 0.98. What is the ratio of the Earning from trade(constant 2005 US) of Lebanon in 2008 to that in 2009?
Your response must be concise. 0.9. What is the ratio of the Earning from trade(constant 2005 US) in Peru in 2008 to that in 2009?
Give a very brief answer. 1.01. What is the difference between the highest and the second highest Earning from trade(constant 2005 US) of Iran?
Your answer should be compact. 1.61e+08. What is the difference between the highest and the second highest Earning from trade(constant 2005 US) of Lebanon?
Your answer should be very brief. 1.15e+09. What is the difference between the highest and the second highest Earning from trade(constant 2005 US) of Peru?
Give a very brief answer. 1.67e+08. What is the difference between the highest and the lowest Earning from trade(constant 2005 US) in Iran?
Provide a short and direct response. 1.44e+1. What is the difference between the highest and the lowest Earning from trade(constant 2005 US) in Lebanon?
Offer a terse response. 5.50e+09. What is the difference between the highest and the lowest Earning from trade(constant 2005 US) of Peru?
Ensure brevity in your answer.  8.84e+09. 